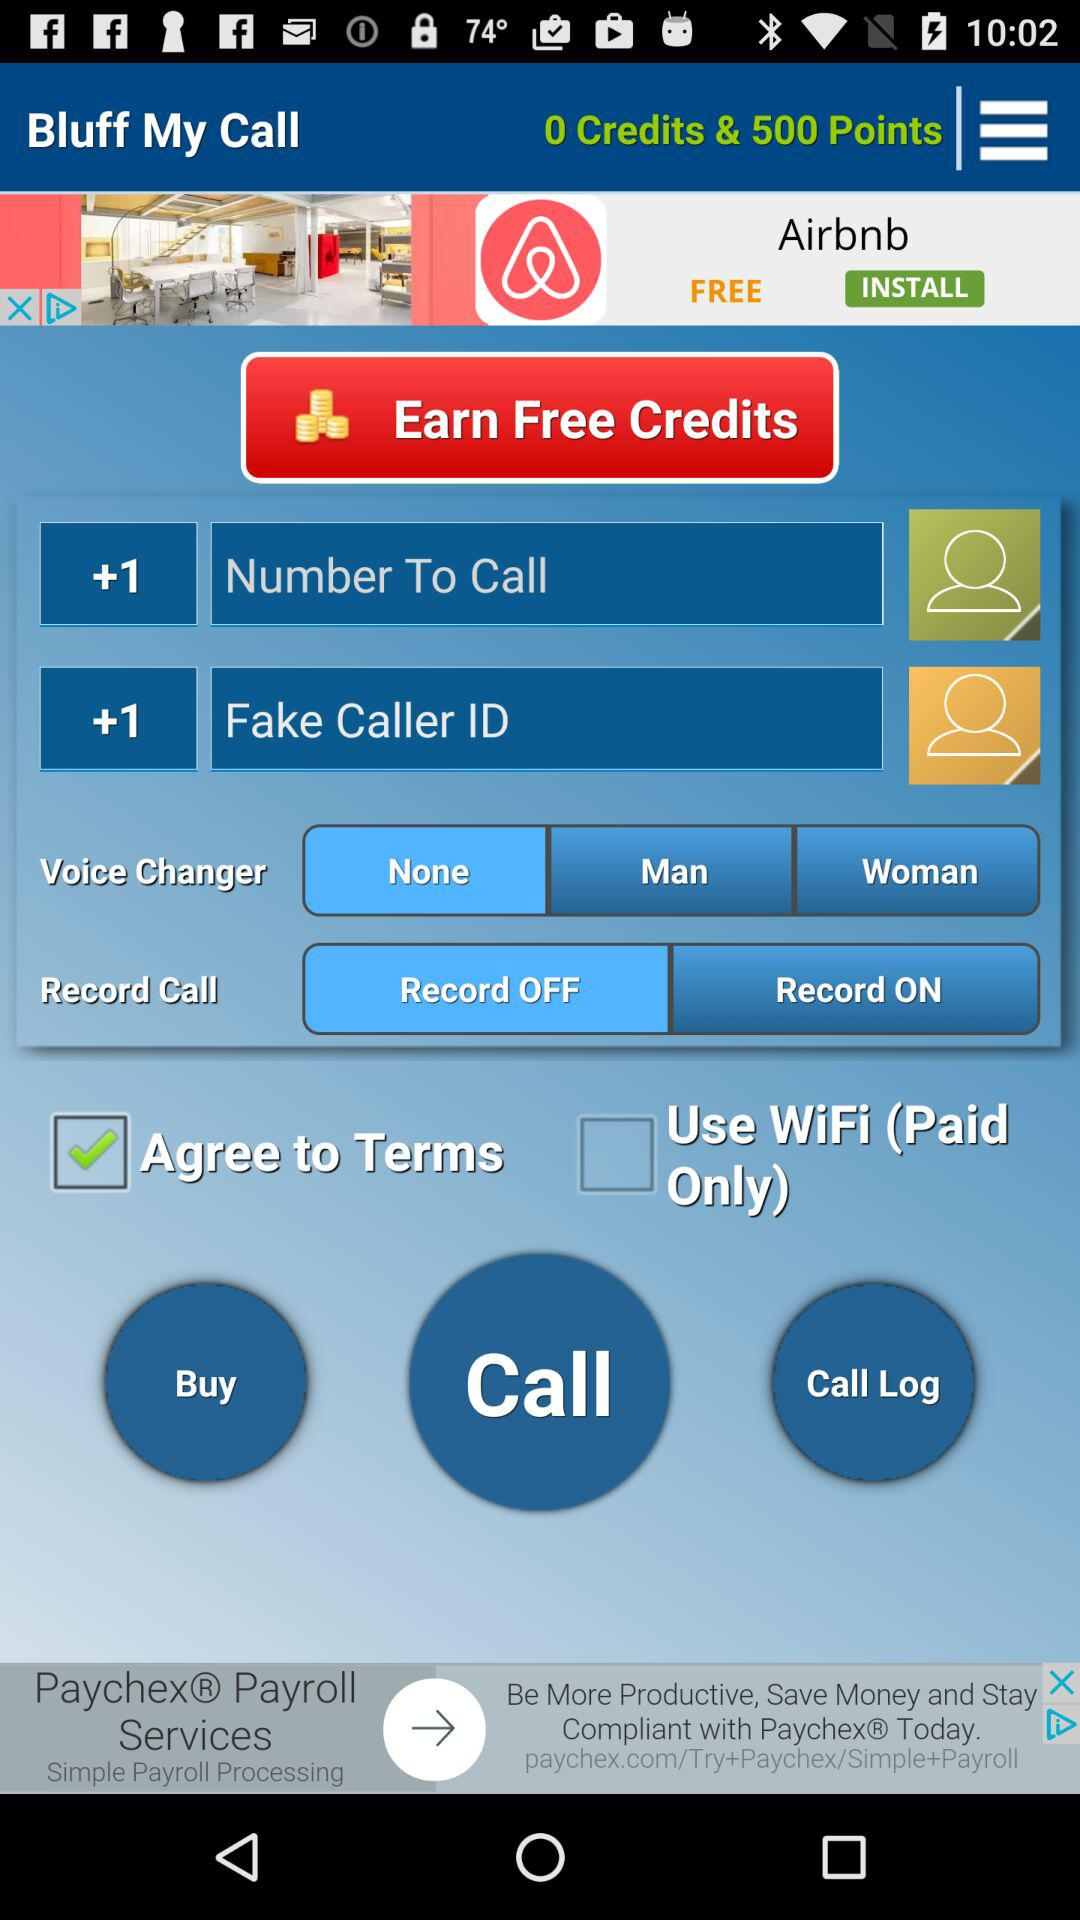How many check boxes are there?
Answer the question using a single word or phrase. 2 